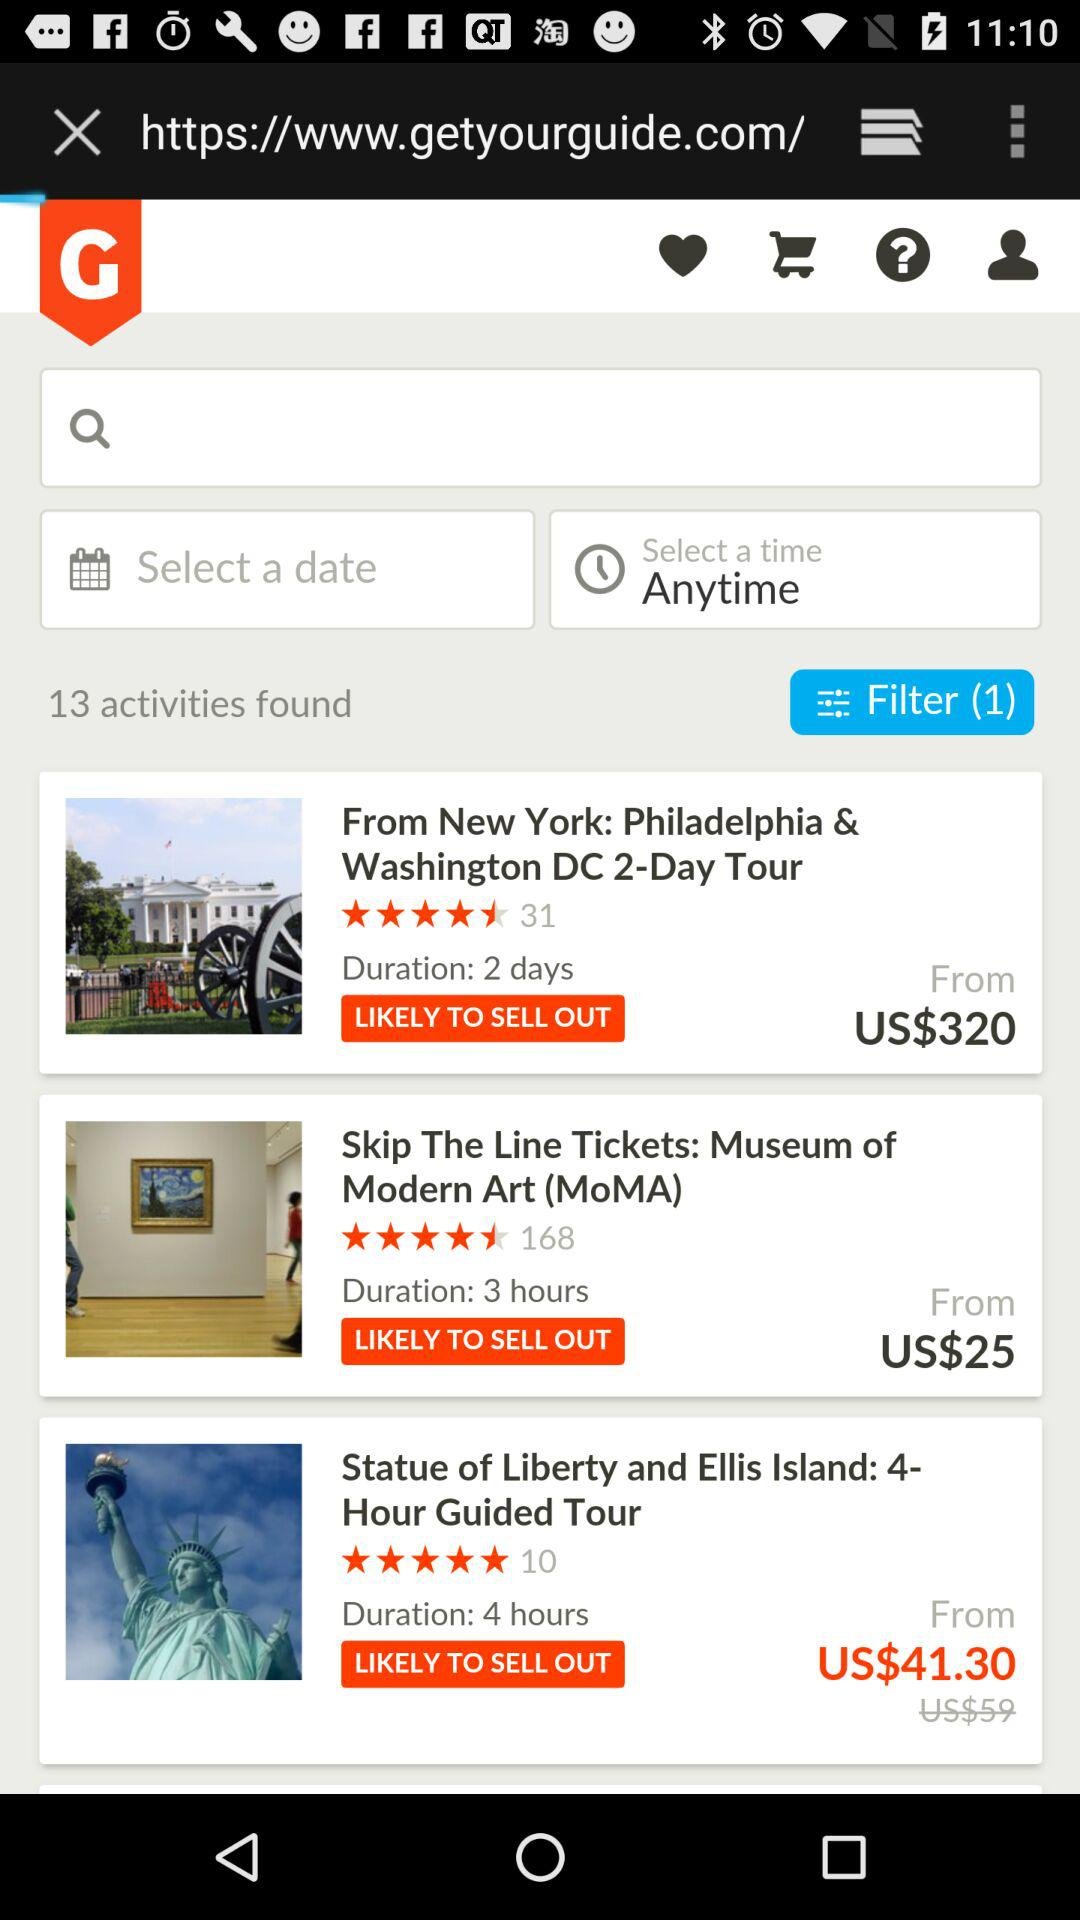What is the duration of the tour to the Statue of Liberty and Ellis Island? The duration of the tour is 4 hours. 